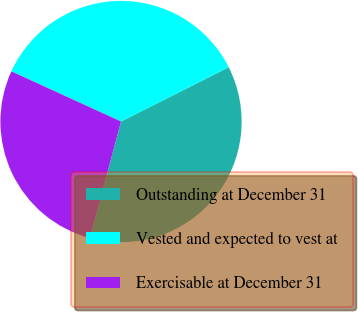<chart> <loc_0><loc_0><loc_500><loc_500><pie_chart><fcel>Outstanding at December 31<fcel>Vested and expected to vest at<fcel>Exercisable at December 31<nl><fcel>36.58%<fcel>35.74%<fcel>27.67%<nl></chart> 